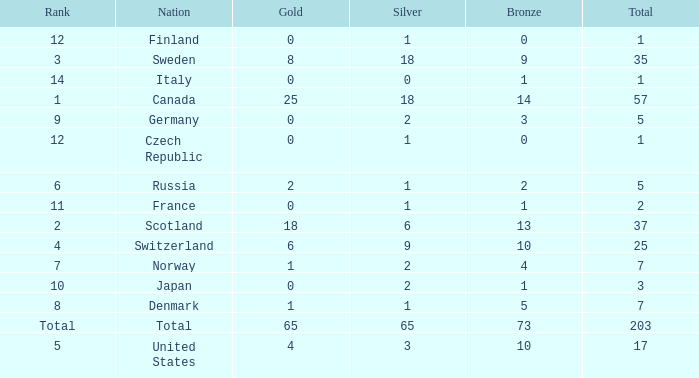What is the lowest total when the rank is 14 and the gold medals is larger than 0? None. 